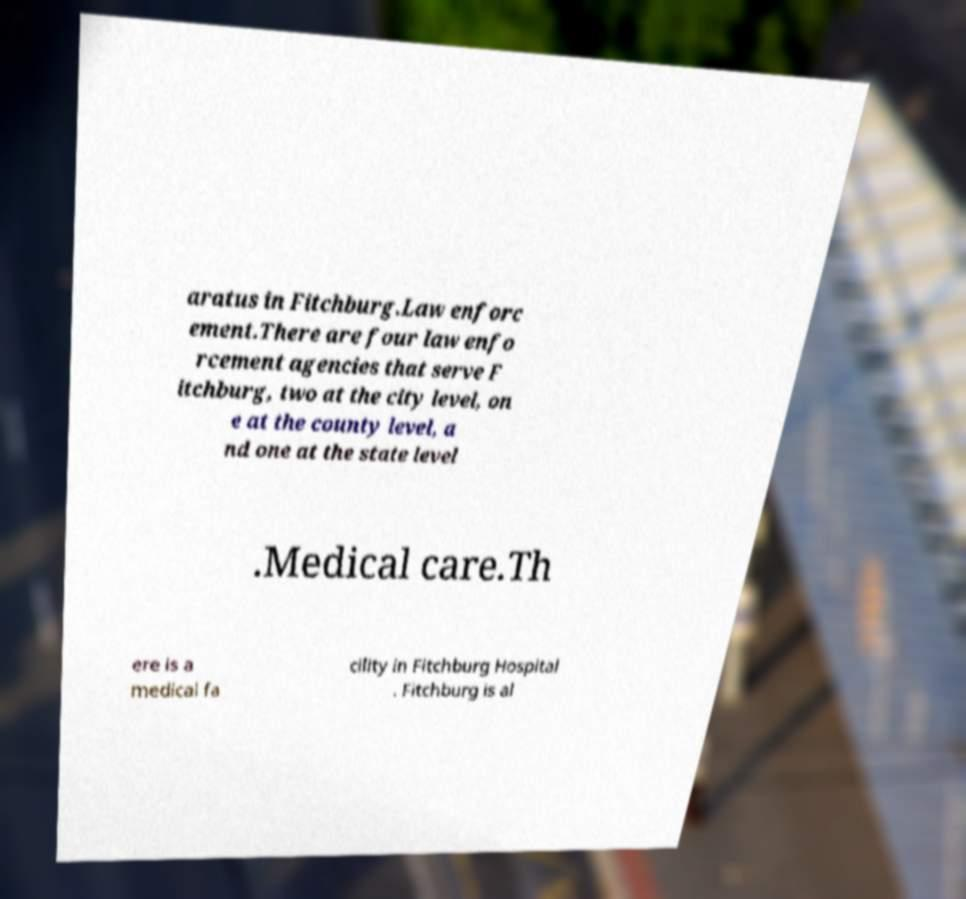Please identify and transcribe the text found in this image. aratus in Fitchburg.Law enforc ement.There are four law enfo rcement agencies that serve F itchburg, two at the city level, on e at the county level, a nd one at the state level .Medical care.Th ere is a medical fa cility in Fitchburg Hospital . Fitchburg is al 